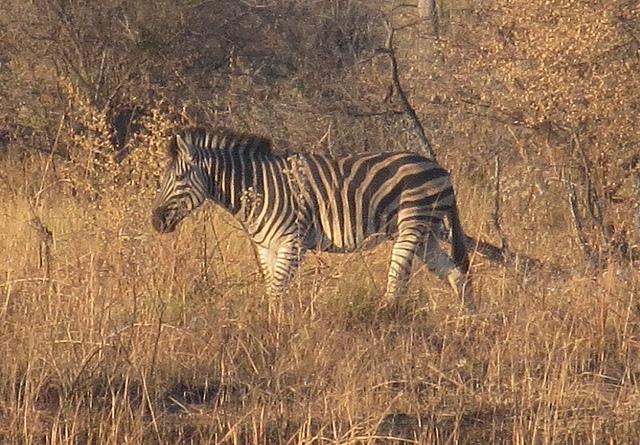Is the zebra facing the camera?
Concise answer only. No. What kind of animals are shown?
Short answer required. Zebra. How many animals are here?
Keep it brief. 1. Is this a wild zebra?
Answer briefly. Yes. What color are the animals stripes?
Short answer required. Black. Is this a young zebra?
Quick response, please. Yes. Are the trees tall enough to provide shade?
Give a very brief answer. No. What is the zebra walking through?
Keep it brief. Grass. How many animals are standing up?
Answer briefly. 1. Are the zebras all looking in the same direction?
Quick response, please. Yes. 